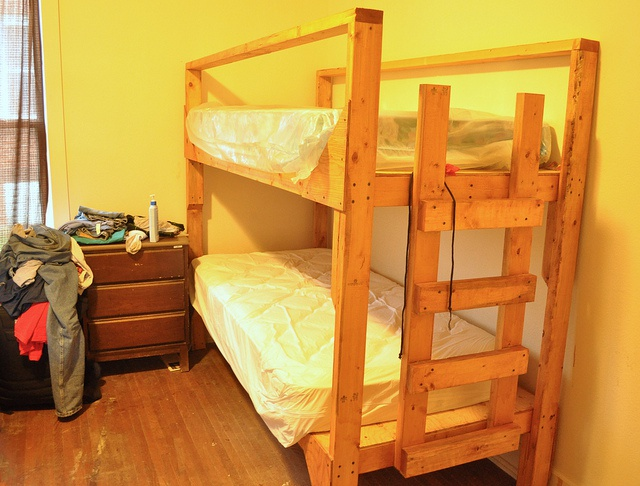Describe the objects in this image and their specific colors. I can see bed in lightgray, red, orange, and khaki tones, suitcase in black, maroon, and lightgray tones, and bottle in lightgray, khaki, tan, and beige tones in this image. 